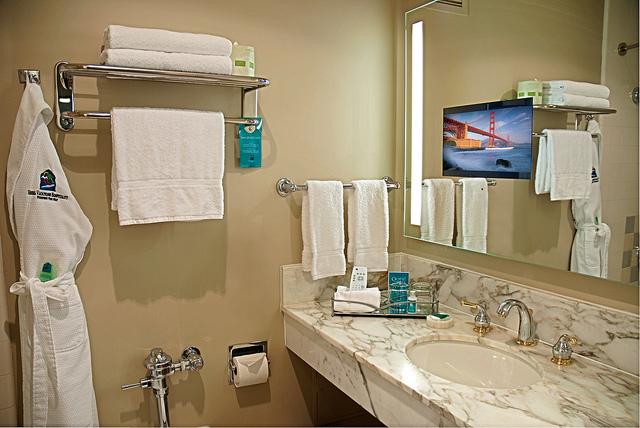Is there a bathroom on one of the hooks?
Quick response, please. No. How many towels are hanging not folded?
Write a very short answer. 3. What is one clue that this is not a private home?
Answer briefly. Tray of toiletries. 